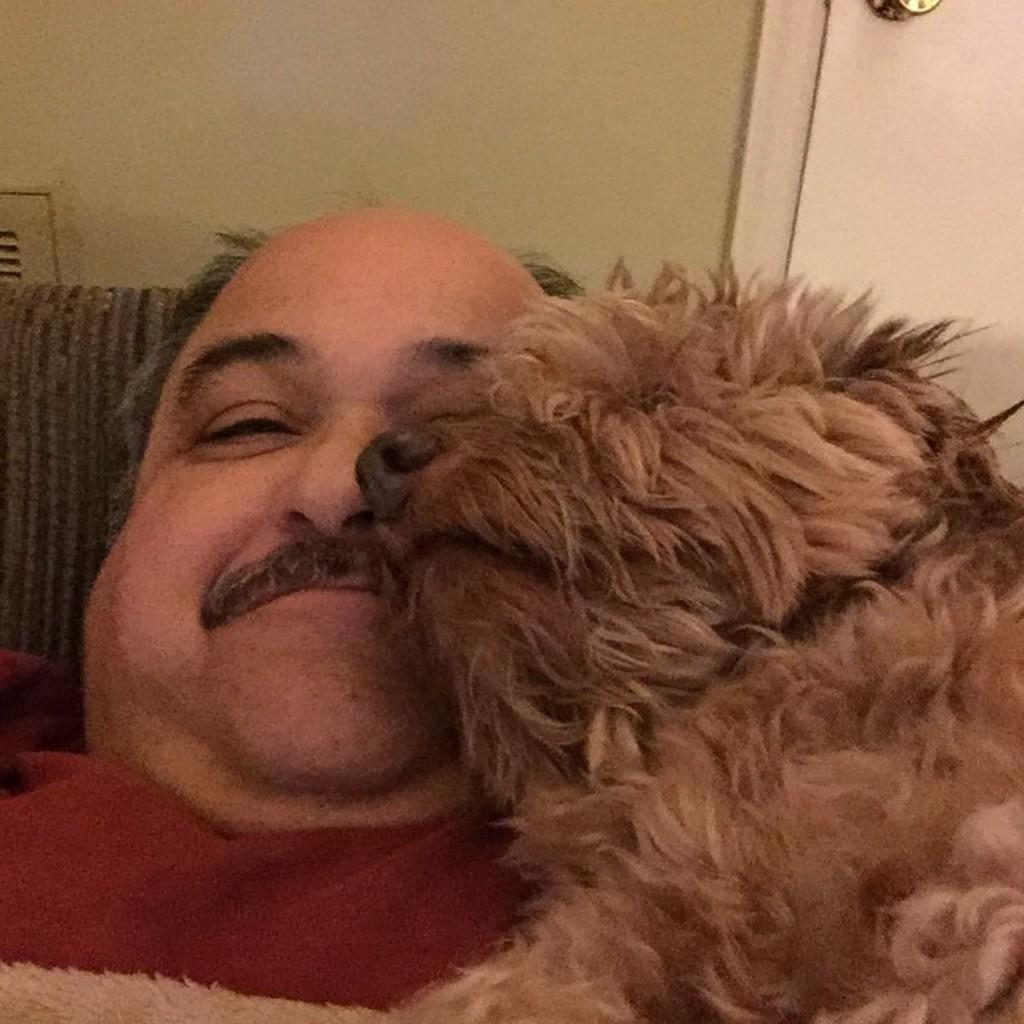What is the person in the image doing? There is a person lying on the bed in the image. Is there any other living creature in the image? Yes, there is a dog near the person in the image. Where is the door located in the image? The door is on the right side of the image. What type of loaf is the person holding in the image? There is no loaf present in the image; the person is lying on the bed. What kind of mist can be seen in the image? There is no mist present in the image; it is an indoor scene with a person lying on the bed and a dog nearby. 